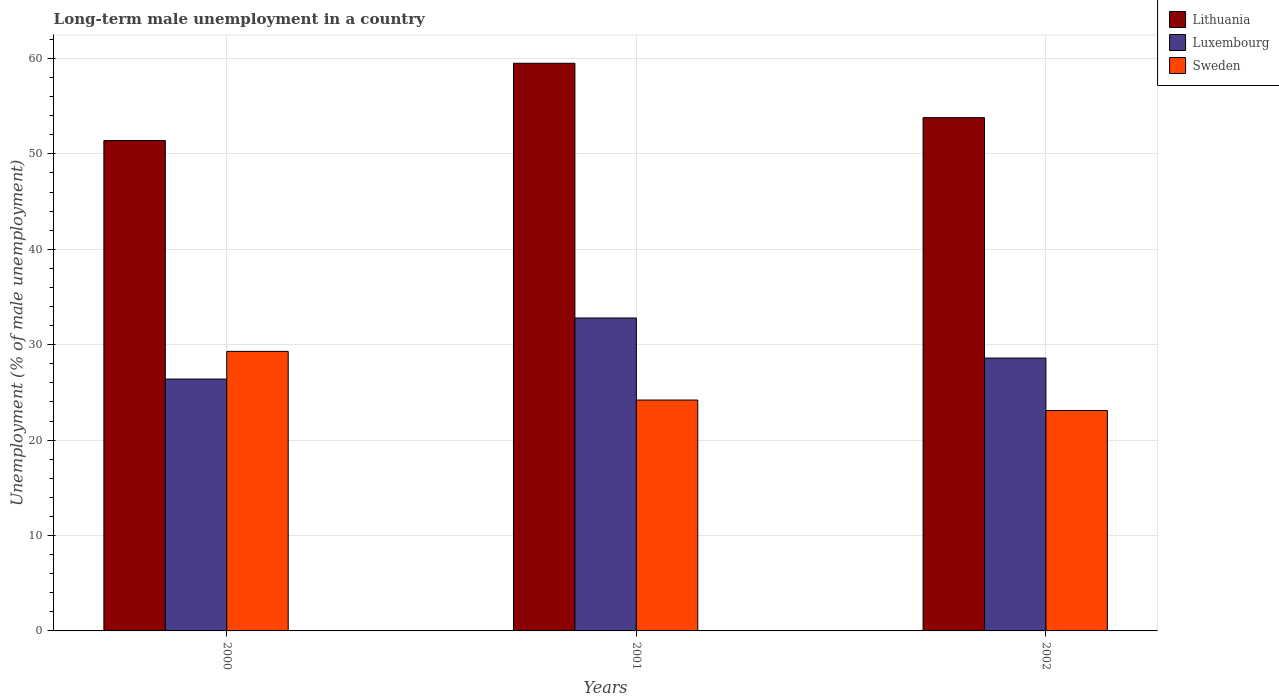How many different coloured bars are there?
Provide a short and direct response. 3. Are the number of bars per tick equal to the number of legend labels?
Give a very brief answer. Yes. How many bars are there on the 2nd tick from the right?
Provide a succinct answer. 3. What is the percentage of long-term unemployed male population in Luxembourg in 2001?
Your answer should be very brief. 32.8. Across all years, what is the maximum percentage of long-term unemployed male population in Luxembourg?
Ensure brevity in your answer.  32.8. Across all years, what is the minimum percentage of long-term unemployed male population in Luxembourg?
Keep it short and to the point. 26.4. In which year was the percentage of long-term unemployed male population in Sweden maximum?
Give a very brief answer. 2000. In which year was the percentage of long-term unemployed male population in Luxembourg minimum?
Offer a terse response. 2000. What is the total percentage of long-term unemployed male population in Lithuania in the graph?
Your answer should be compact. 164.7. What is the difference between the percentage of long-term unemployed male population in Sweden in 2000 and that in 2001?
Keep it short and to the point. 5.1. What is the difference between the percentage of long-term unemployed male population in Sweden in 2000 and the percentage of long-term unemployed male population in Lithuania in 2001?
Offer a very short reply. -30.2. What is the average percentage of long-term unemployed male population in Lithuania per year?
Provide a short and direct response. 54.9. In the year 2001, what is the difference between the percentage of long-term unemployed male population in Lithuania and percentage of long-term unemployed male population in Sweden?
Make the answer very short. 35.3. In how many years, is the percentage of long-term unemployed male population in Lithuania greater than 18 %?
Keep it short and to the point. 3. What is the ratio of the percentage of long-term unemployed male population in Sweden in 2001 to that in 2002?
Provide a succinct answer. 1.05. Is the difference between the percentage of long-term unemployed male population in Lithuania in 2001 and 2002 greater than the difference between the percentage of long-term unemployed male population in Sweden in 2001 and 2002?
Give a very brief answer. Yes. What is the difference between the highest and the second highest percentage of long-term unemployed male population in Luxembourg?
Ensure brevity in your answer.  4.2. What is the difference between the highest and the lowest percentage of long-term unemployed male population in Sweden?
Your answer should be very brief. 6.2. What does the 3rd bar from the left in 2000 represents?
Provide a short and direct response. Sweden. What does the 3rd bar from the right in 2002 represents?
Provide a succinct answer. Lithuania. How many bars are there?
Your answer should be compact. 9. Are all the bars in the graph horizontal?
Offer a very short reply. No. What is the difference between two consecutive major ticks on the Y-axis?
Give a very brief answer. 10. Does the graph contain any zero values?
Keep it short and to the point. No. Does the graph contain grids?
Your answer should be compact. Yes. Where does the legend appear in the graph?
Your response must be concise. Top right. How many legend labels are there?
Offer a terse response. 3. What is the title of the graph?
Your answer should be very brief. Long-term male unemployment in a country. What is the label or title of the Y-axis?
Your response must be concise. Unemployment (% of male unemployment). What is the Unemployment (% of male unemployment) in Lithuania in 2000?
Your answer should be compact. 51.4. What is the Unemployment (% of male unemployment) of Luxembourg in 2000?
Provide a succinct answer. 26.4. What is the Unemployment (% of male unemployment) in Sweden in 2000?
Keep it short and to the point. 29.3. What is the Unemployment (% of male unemployment) in Lithuania in 2001?
Make the answer very short. 59.5. What is the Unemployment (% of male unemployment) in Luxembourg in 2001?
Provide a short and direct response. 32.8. What is the Unemployment (% of male unemployment) of Sweden in 2001?
Provide a short and direct response. 24.2. What is the Unemployment (% of male unemployment) in Lithuania in 2002?
Give a very brief answer. 53.8. What is the Unemployment (% of male unemployment) in Luxembourg in 2002?
Offer a terse response. 28.6. What is the Unemployment (% of male unemployment) in Sweden in 2002?
Your answer should be very brief. 23.1. Across all years, what is the maximum Unemployment (% of male unemployment) in Lithuania?
Your answer should be compact. 59.5. Across all years, what is the maximum Unemployment (% of male unemployment) in Luxembourg?
Make the answer very short. 32.8. Across all years, what is the maximum Unemployment (% of male unemployment) of Sweden?
Keep it short and to the point. 29.3. Across all years, what is the minimum Unemployment (% of male unemployment) of Lithuania?
Your answer should be very brief. 51.4. Across all years, what is the minimum Unemployment (% of male unemployment) of Luxembourg?
Offer a terse response. 26.4. Across all years, what is the minimum Unemployment (% of male unemployment) of Sweden?
Provide a succinct answer. 23.1. What is the total Unemployment (% of male unemployment) in Lithuania in the graph?
Offer a terse response. 164.7. What is the total Unemployment (% of male unemployment) of Luxembourg in the graph?
Keep it short and to the point. 87.8. What is the total Unemployment (% of male unemployment) of Sweden in the graph?
Offer a very short reply. 76.6. What is the difference between the Unemployment (% of male unemployment) in Lithuania in 2000 and that in 2002?
Your answer should be very brief. -2.4. What is the difference between the Unemployment (% of male unemployment) of Sweden in 2000 and that in 2002?
Provide a short and direct response. 6.2. What is the difference between the Unemployment (% of male unemployment) in Lithuania in 2001 and that in 2002?
Provide a short and direct response. 5.7. What is the difference between the Unemployment (% of male unemployment) in Sweden in 2001 and that in 2002?
Make the answer very short. 1.1. What is the difference between the Unemployment (% of male unemployment) in Lithuania in 2000 and the Unemployment (% of male unemployment) in Sweden in 2001?
Make the answer very short. 27.2. What is the difference between the Unemployment (% of male unemployment) of Luxembourg in 2000 and the Unemployment (% of male unemployment) of Sweden in 2001?
Ensure brevity in your answer.  2.2. What is the difference between the Unemployment (% of male unemployment) in Lithuania in 2000 and the Unemployment (% of male unemployment) in Luxembourg in 2002?
Ensure brevity in your answer.  22.8. What is the difference between the Unemployment (% of male unemployment) in Lithuania in 2000 and the Unemployment (% of male unemployment) in Sweden in 2002?
Offer a very short reply. 28.3. What is the difference between the Unemployment (% of male unemployment) in Lithuania in 2001 and the Unemployment (% of male unemployment) in Luxembourg in 2002?
Offer a terse response. 30.9. What is the difference between the Unemployment (% of male unemployment) of Lithuania in 2001 and the Unemployment (% of male unemployment) of Sweden in 2002?
Offer a very short reply. 36.4. What is the difference between the Unemployment (% of male unemployment) in Luxembourg in 2001 and the Unemployment (% of male unemployment) in Sweden in 2002?
Ensure brevity in your answer.  9.7. What is the average Unemployment (% of male unemployment) in Lithuania per year?
Offer a terse response. 54.9. What is the average Unemployment (% of male unemployment) in Luxembourg per year?
Your answer should be compact. 29.27. What is the average Unemployment (% of male unemployment) in Sweden per year?
Your answer should be compact. 25.53. In the year 2000, what is the difference between the Unemployment (% of male unemployment) of Lithuania and Unemployment (% of male unemployment) of Luxembourg?
Your response must be concise. 25. In the year 2000, what is the difference between the Unemployment (% of male unemployment) in Lithuania and Unemployment (% of male unemployment) in Sweden?
Provide a succinct answer. 22.1. In the year 2000, what is the difference between the Unemployment (% of male unemployment) in Luxembourg and Unemployment (% of male unemployment) in Sweden?
Provide a short and direct response. -2.9. In the year 2001, what is the difference between the Unemployment (% of male unemployment) in Lithuania and Unemployment (% of male unemployment) in Luxembourg?
Offer a terse response. 26.7. In the year 2001, what is the difference between the Unemployment (% of male unemployment) in Lithuania and Unemployment (% of male unemployment) in Sweden?
Provide a short and direct response. 35.3. In the year 2001, what is the difference between the Unemployment (% of male unemployment) in Luxembourg and Unemployment (% of male unemployment) in Sweden?
Keep it short and to the point. 8.6. In the year 2002, what is the difference between the Unemployment (% of male unemployment) of Lithuania and Unemployment (% of male unemployment) of Luxembourg?
Keep it short and to the point. 25.2. In the year 2002, what is the difference between the Unemployment (% of male unemployment) of Lithuania and Unemployment (% of male unemployment) of Sweden?
Provide a short and direct response. 30.7. In the year 2002, what is the difference between the Unemployment (% of male unemployment) in Luxembourg and Unemployment (% of male unemployment) in Sweden?
Your answer should be very brief. 5.5. What is the ratio of the Unemployment (% of male unemployment) in Lithuania in 2000 to that in 2001?
Provide a short and direct response. 0.86. What is the ratio of the Unemployment (% of male unemployment) of Luxembourg in 2000 to that in 2001?
Your answer should be compact. 0.8. What is the ratio of the Unemployment (% of male unemployment) of Sweden in 2000 to that in 2001?
Give a very brief answer. 1.21. What is the ratio of the Unemployment (% of male unemployment) in Lithuania in 2000 to that in 2002?
Offer a terse response. 0.96. What is the ratio of the Unemployment (% of male unemployment) of Luxembourg in 2000 to that in 2002?
Your response must be concise. 0.92. What is the ratio of the Unemployment (% of male unemployment) of Sweden in 2000 to that in 2002?
Keep it short and to the point. 1.27. What is the ratio of the Unemployment (% of male unemployment) of Lithuania in 2001 to that in 2002?
Give a very brief answer. 1.11. What is the ratio of the Unemployment (% of male unemployment) of Luxembourg in 2001 to that in 2002?
Provide a succinct answer. 1.15. What is the ratio of the Unemployment (% of male unemployment) in Sweden in 2001 to that in 2002?
Your response must be concise. 1.05. What is the difference between the highest and the second highest Unemployment (% of male unemployment) of Lithuania?
Keep it short and to the point. 5.7. What is the difference between the highest and the lowest Unemployment (% of male unemployment) of Luxembourg?
Provide a succinct answer. 6.4. What is the difference between the highest and the lowest Unemployment (% of male unemployment) in Sweden?
Offer a very short reply. 6.2. 